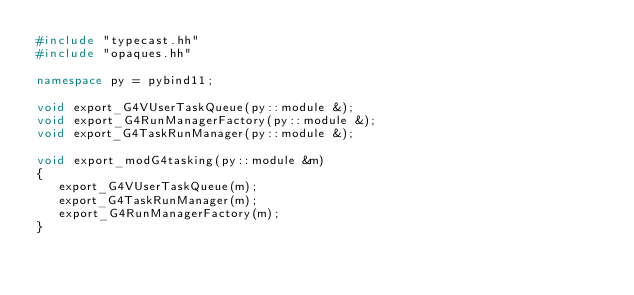Convert code to text. <code><loc_0><loc_0><loc_500><loc_500><_C++_>#include "typecast.hh"
#include "opaques.hh"

namespace py = pybind11;

void export_G4VUserTaskQueue(py::module &);
void export_G4RunManagerFactory(py::module &);
void export_G4TaskRunManager(py::module &);

void export_modG4tasking(py::module &m)
{
   export_G4VUserTaskQueue(m);
   export_G4TaskRunManager(m);
   export_G4RunManagerFactory(m);
}
</code> 